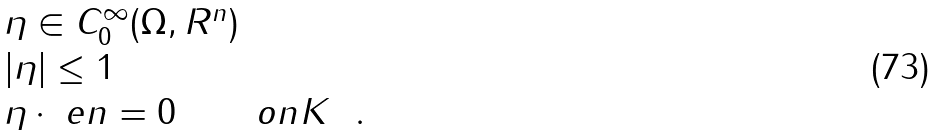Convert formula to latex. <formula><loc_0><loc_0><loc_500><loc_500>\begin{array} { l l } \eta \in C ^ { \infty } _ { 0 } ( \Omega , R ^ { n } ) & \\ | \eta | \leq 1 & \\ \eta \cdot \ e n = 0 & o n K \ \ . \end{array}</formula> 